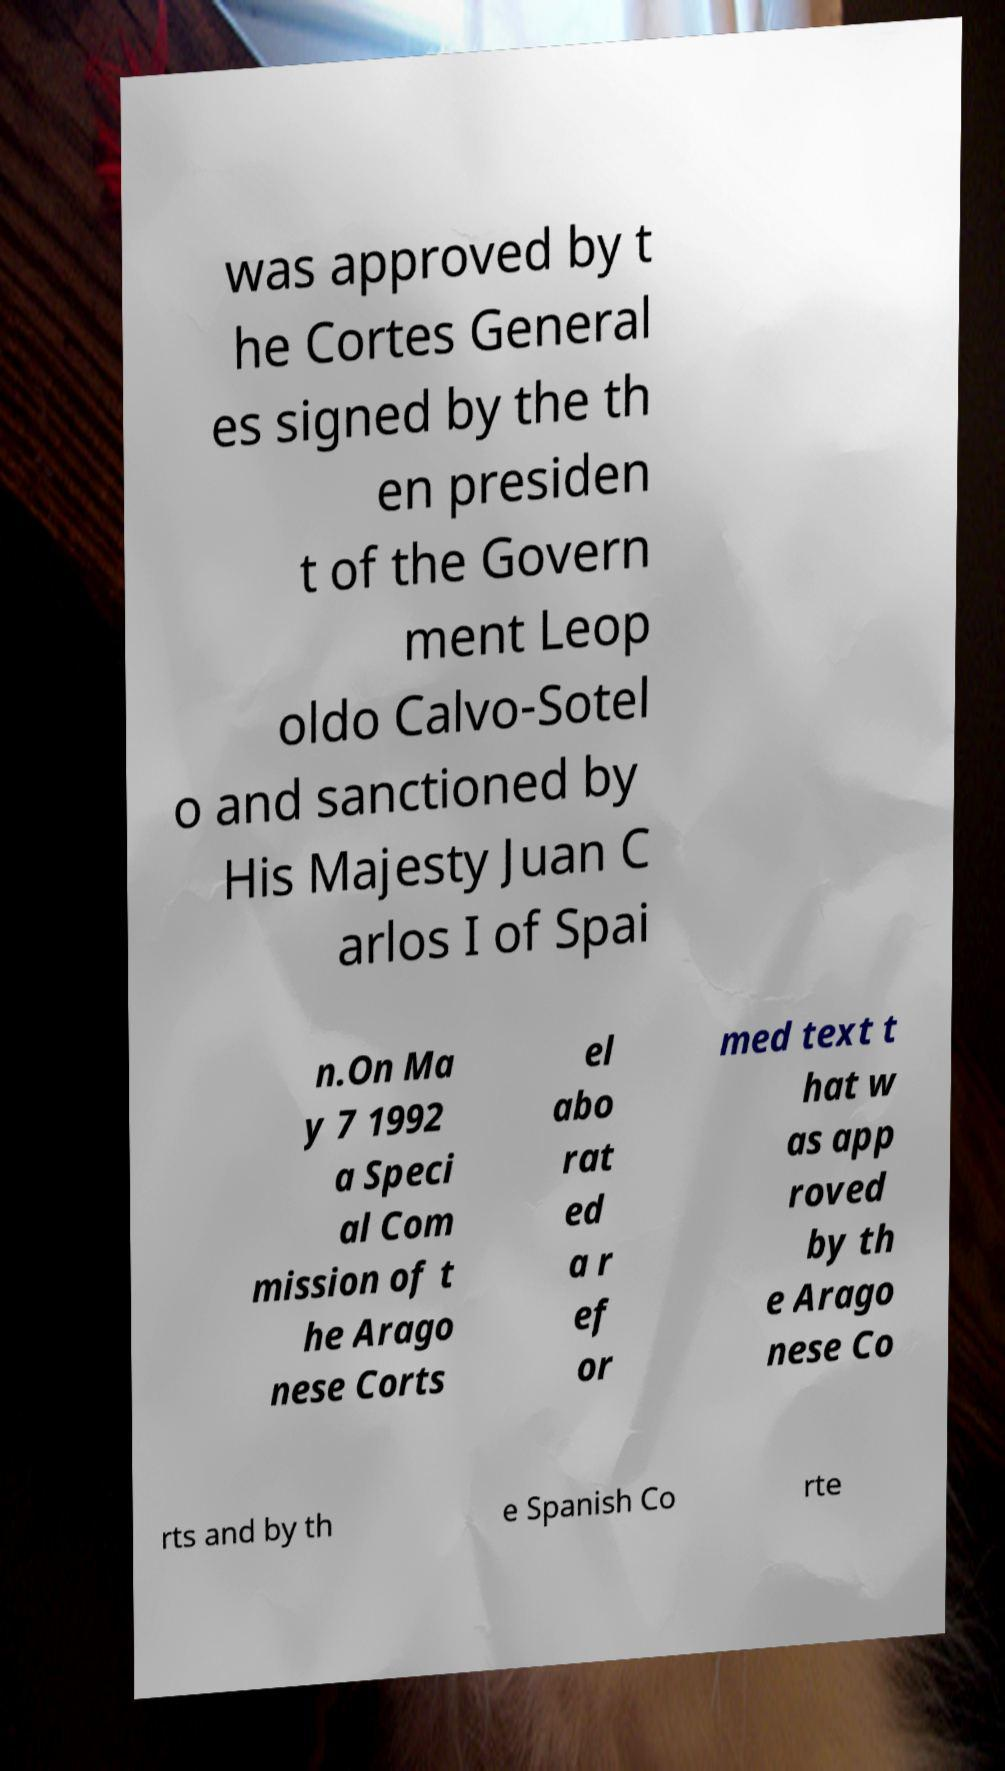Can you read and provide the text displayed in the image?This photo seems to have some interesting text. Can you extract and type it out for me? was approved by t he Cortes General es signed by the th en presiden t of the Govern ment Leop oldo Calvo-Sotel o and sanctioned by His Majesty Juan C arlos I of Spai n.On Ma y 7 1992 a Speci al Com mission of t he Arago nese Corts el abo rat ed a r ef or med text t hat w as app roved by th e Arago nese Co rts and by th e Spanish Co rte 